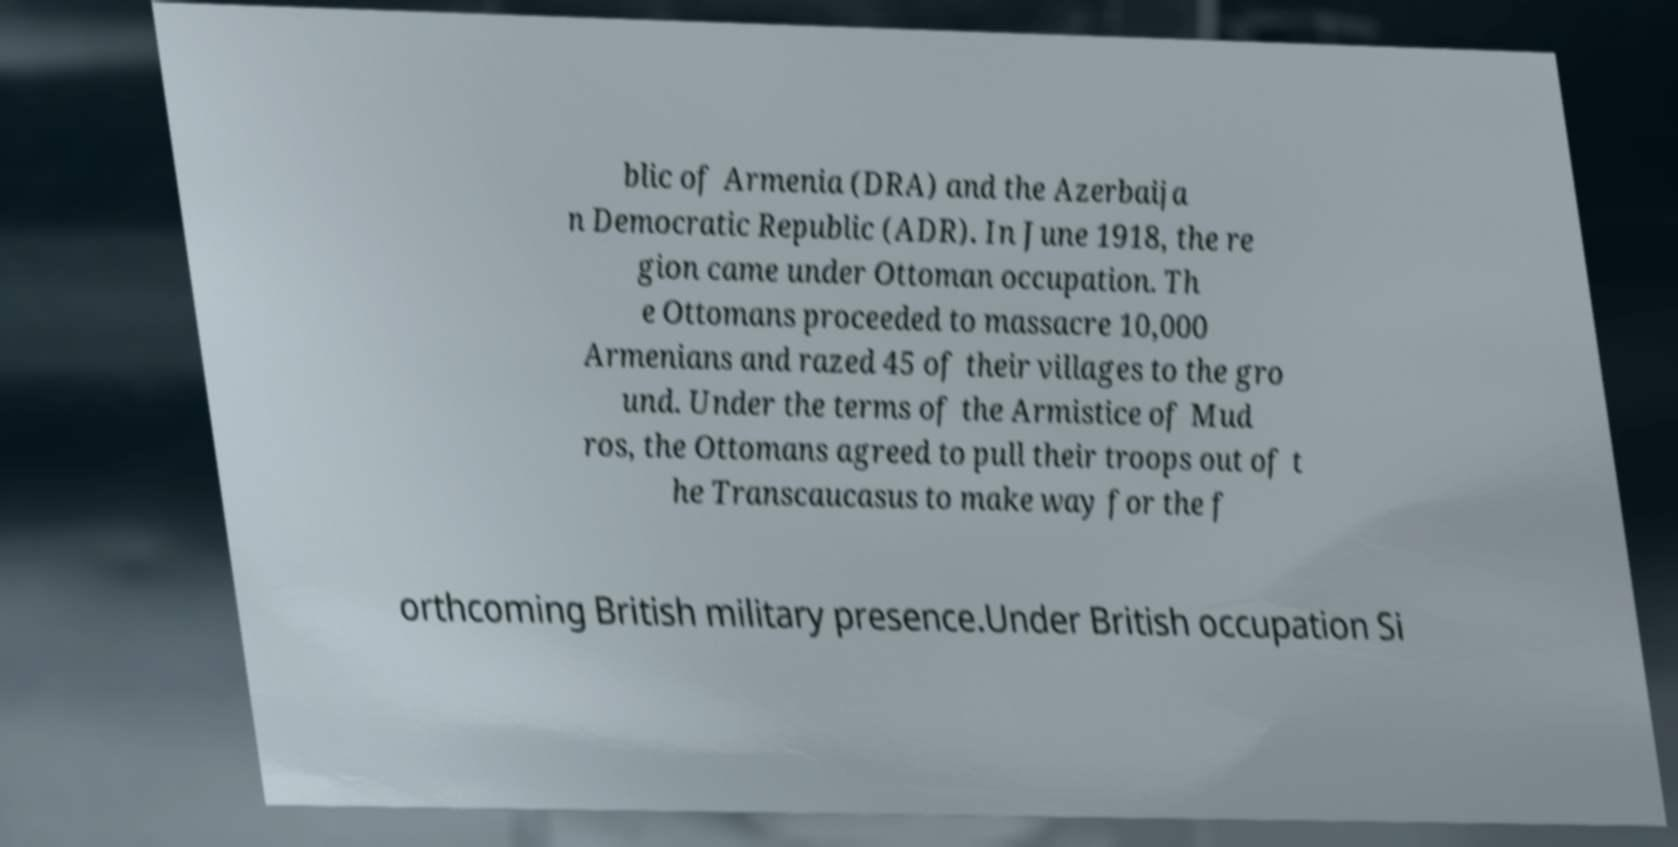What messages or text are displayed in this image? I need them in a readable, typed format. blic of Armenia (DRA) and the Azerbaija n Democratic Republic (ADR). In June 1918, the re gion came under Ottoman occupation. Th e Ottomans proceeded to massacre 10,000 Armenians and razed 45 of their villages to the gro und. Under the terms of the Armistice of Mud ros, the Ottomans agreed to pull their troops out of t he Transcaucasus to make way for the f orthcoming British military presence.Under British occupation Si 